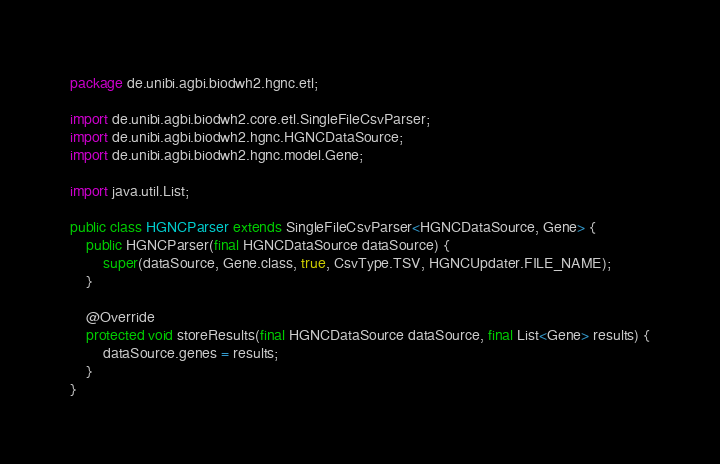Convert code to text. <code><loc_0><loc_0><loc_500><loc_500><_Java_>package de.unibi.agbi.biodwh2.hgnc.etl;

import de.unibi.agbi.biodwh2.core.etl.SingleFileCsvParser;
import de.unibi.agbi.biodwh2.hgnc.HGNCDataSource;
import de.unibi.agbi.biodwh2.hgnc.model.Gene;

import java.util.List;

public class HGNCParser extends SingleFileCsvParser<HGNCDataSource, Gene> {
    public HGNCParser(final HGNCDataSource dataSource) {
        super(dataSource, Gene.class, true, CsvType.TSV, HGNCUpdater.FILE_NAME);
    }

    @Override
    protected void storeResults(final HGNCDataSource dataSource, final List<Gene> results) {
        dataSource.genes = results;
    }
}
</code> 